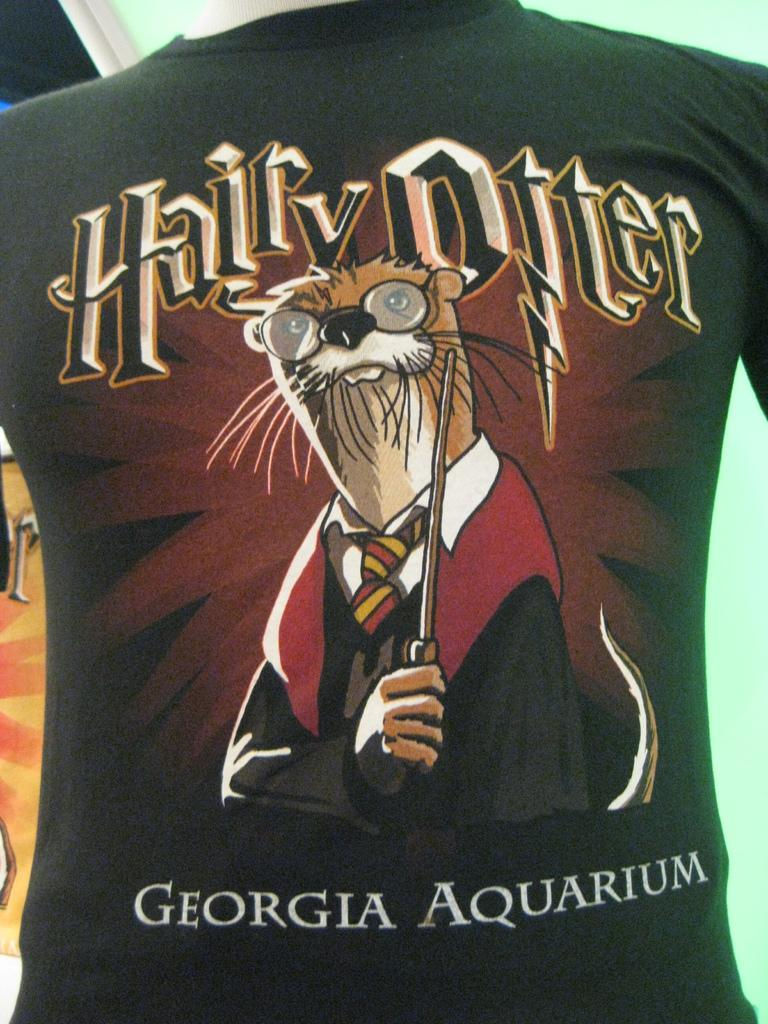What color is the t-shirt in the image? The t-shirt in the image is black. What is written or printed on the t-shirt? The t-shirt has some text on it. What type of building is depicted on the t-shirt? There is no building depicted on the t-shirt; it only has text on it. What material is the ring made of that is shown on the t-shirt? There is no ring shown on the t-shirt; it only has text on it. 